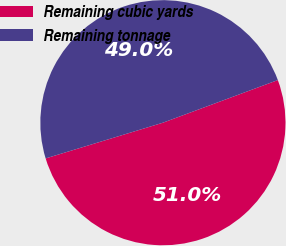<chart> <loc_0><loc_0><loc_500><loc_500><pie_chart><fcel>Remaining cubic yards<fcel>Remaining tonnage<nl><fcel>50.95%<fcel>49.05%<nl></chart> 